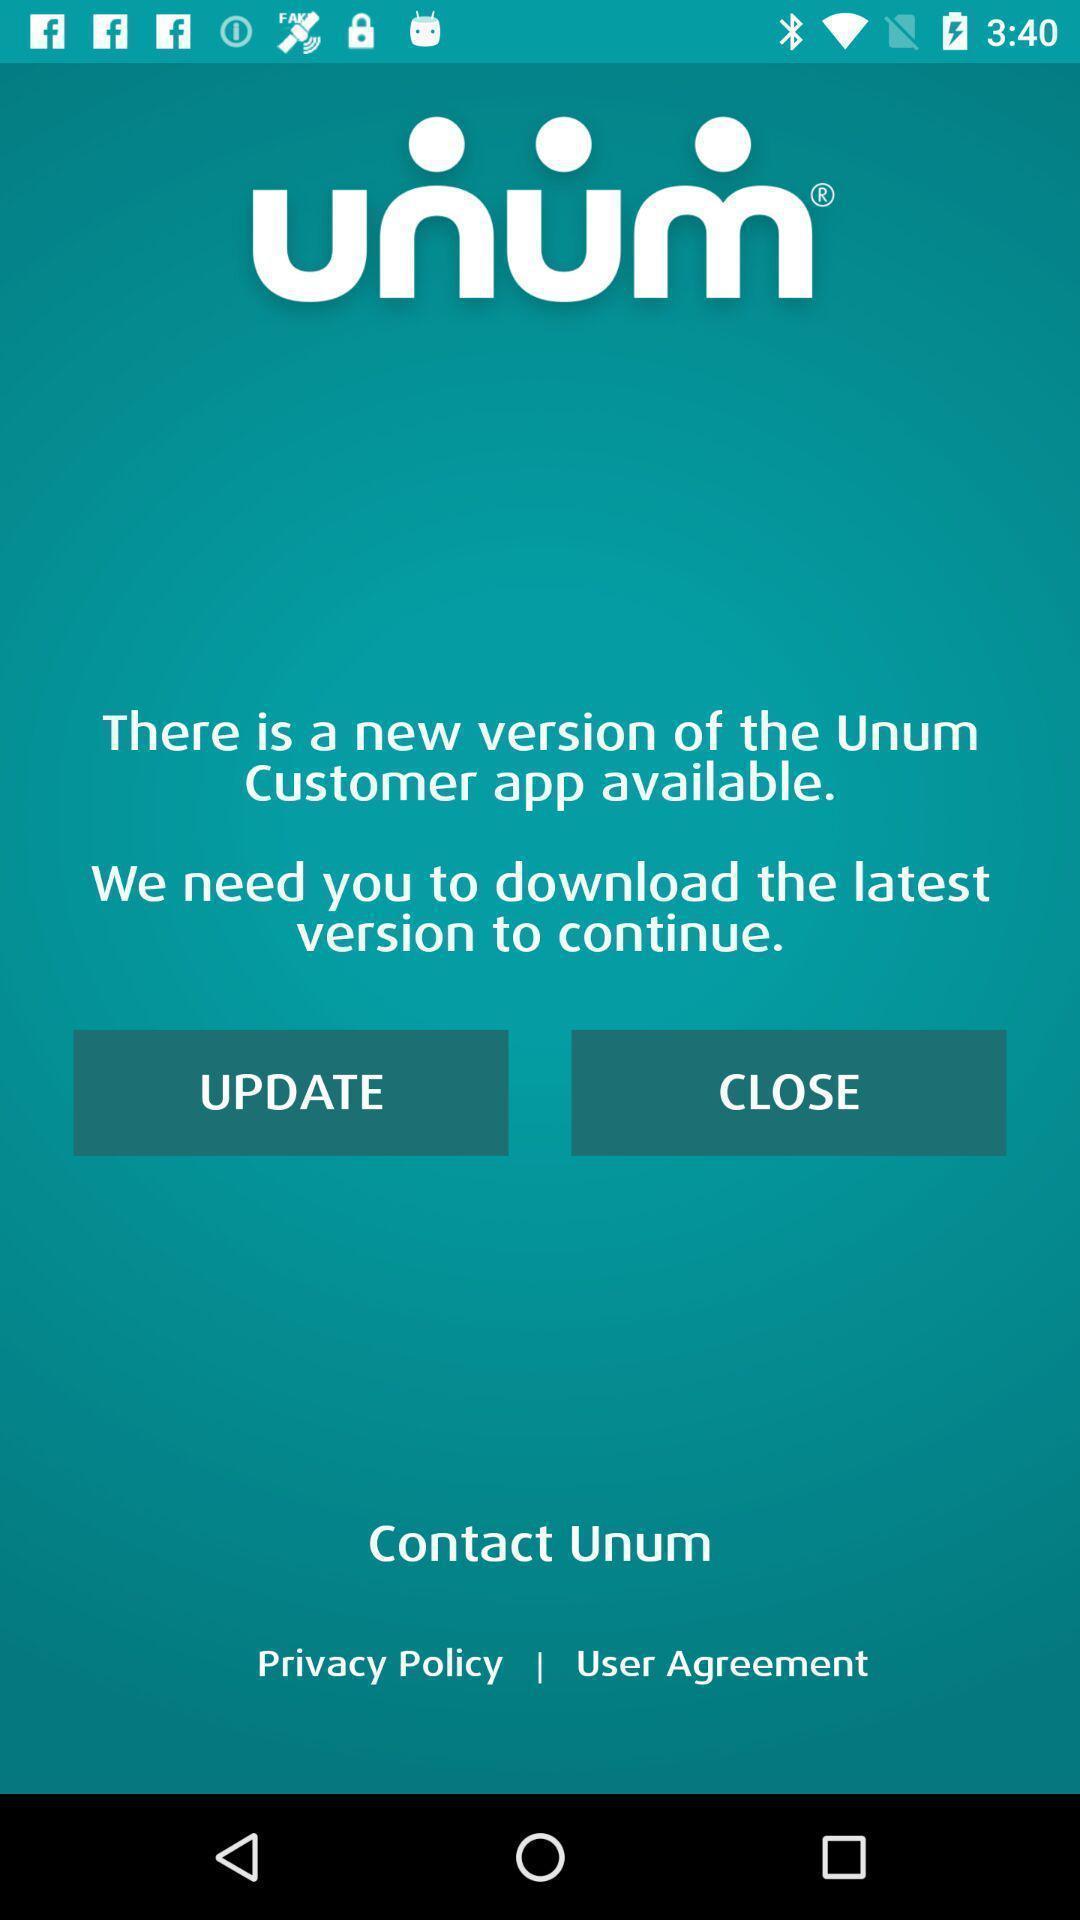Provide a textual representation of this image. Update in the application for the new version. 